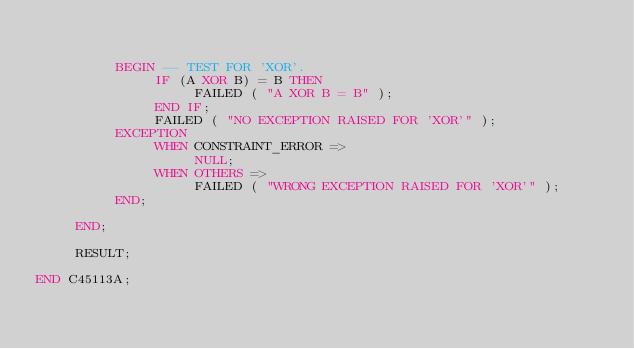<code> <loc_0><loc_0><loc_500><loc_500><_Ada_>

          BEGIN -- TEST FOR 'XOR'.
               IF (A XOR B) = B THEN
                    FAILED ( "A XOR B = B" );
               END IF;
               FAILED ( "NO EXCEPTION RAISED FOR 'XOR'" );
          EXCEPTION
               WHEN CONSTRAINT_ERROR => 
                    NULL;
               WHEN OTHERS =>
                    FAILED ( "WRONG EXCEPTION RAISED FOR 'XOR'" );
          END;           

     END;

     RESULT;

END C45113A;
</code> 